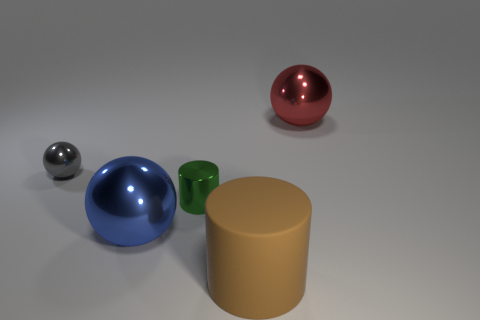Subtract all balls. How many objects are left? 2 Add 2 big green shiny things. How many big green shiny things exist? 2 Add 2 red things. How many objects exist? 7 Subtract all gray spheres. How many spheres are left? 2 Subtract all big blue metal balls. How many balls are left? 2 Subtract 0 brown spheres. How many objects are left? 5 Subtract 1 balls. How many balls are left? 2 Subtract all brown spheres. Subtract all red cylinders. How many spheres are left? 3 Subtract all gray cylinders. How many red spheres are left? 1 Subtract all brown things. Subtract all large purple matte objects. How many objects are left? 4 